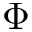<formula> <loc_0><loc_0><loc_500><loc_500>\Phi</formula> 